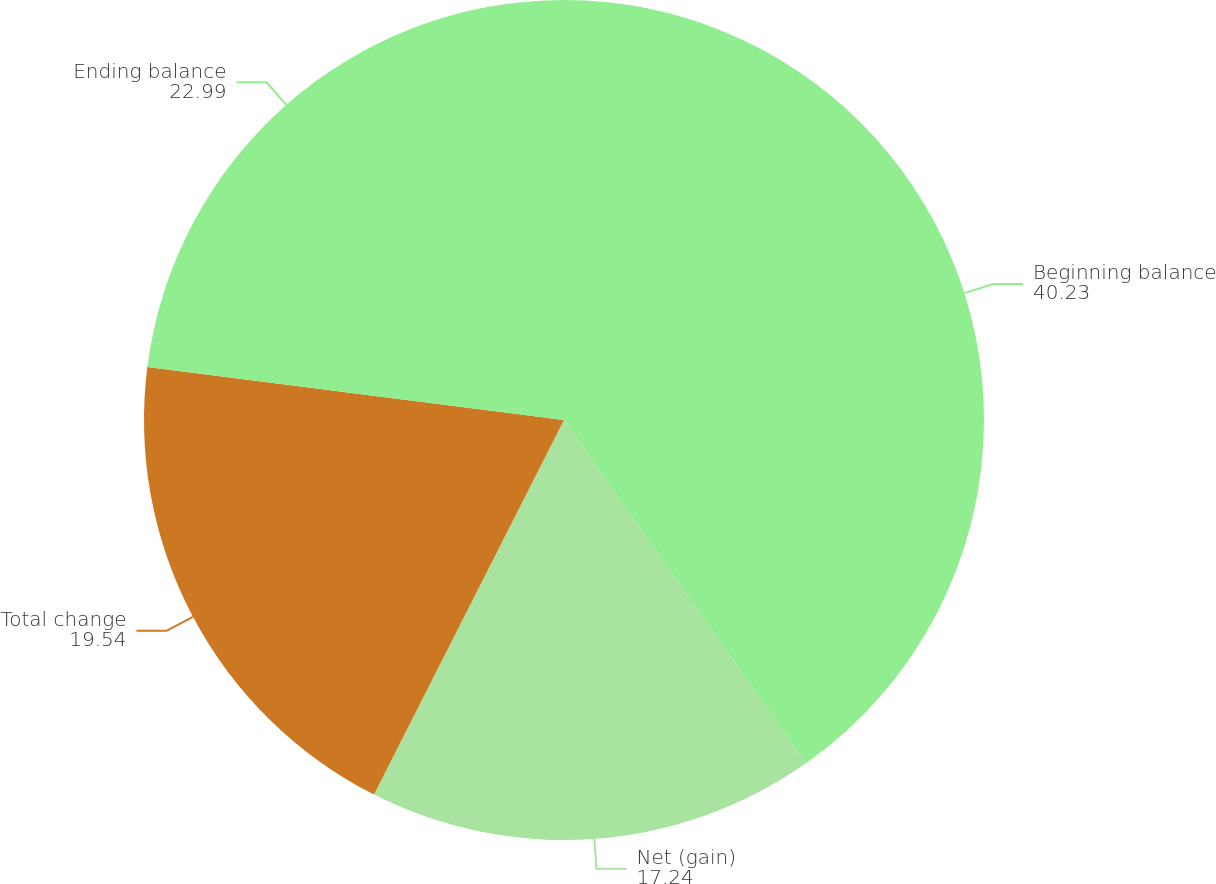<chart> <loc_0><loc_0><loc_500><loc_500><pie_chart><fcel>Beginning balance<fcel>Net (gain)<fcel>Total change<fcel>Ending balance<nl><fcel>40.23%<fcel>17.24%<fcel>19.54%<fcel>22.99%<nl></chart> 